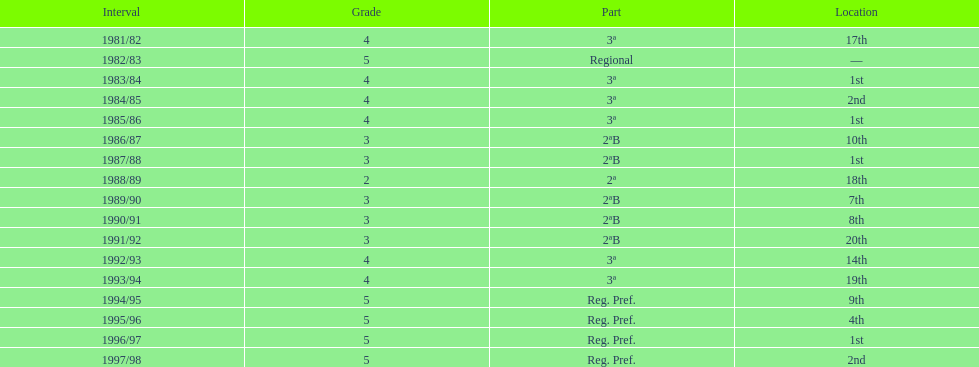In which year was the team's poorest season? 1991/92. 